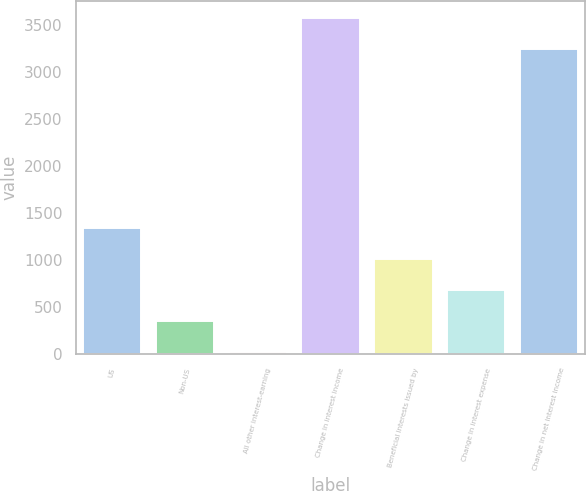<chart> <loc_0><loc_0><loc_500><loc_500><bar_chart><fcel>US<fcel>Non-US<fcel>All other interest-earning<fcel>Change in interest income<fcel>Beneficial interests issued by<fcel>Change in interest expense<fcel>Change in net interest income<nl><fcel>1336.6<fcel>349.9<fcel>21<fcel>3573.9<fcel>1007.7<fcel>678.8<fcel>3245<nl></chart> 